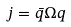<formula> <loc_0><loc_0><loc_500><loc_500>j = \bar { q } \Omega q</formula> 